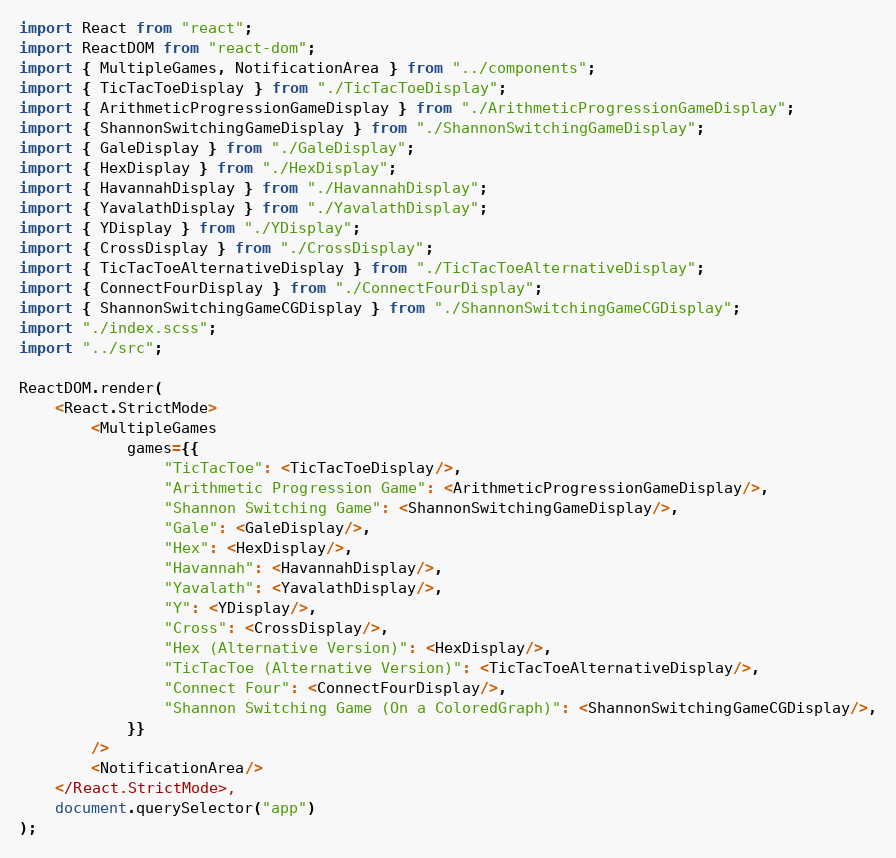Convert code to text. <code><loc_0><loc_0><loc_500><loc_500><_TypeScript_>import React from "react";
import ReactDOM from "react-dom";
import { MultipleGames, NotificationArea } from "../components";
import { TicTacToeDisplay } from "./TicTacToeDisplay";
import { ArithmeticProgressionGameDisplay } from "./ArithmeticProgressionGameDisplay";
import { ShannonSwitchingGameDisplay } from "./ShannonSwitchingGameDisplay";
import { GaleDisplay } from "./GaleDisplay";
import { HexDisplay } from "./HexDisplay";
import { HavannahDisplay } from "./HavannahDisplay";
import { YavalathDisplay } from "./YavalathDisplay";
import { YDisplay } from "./YDisplay";
import { CrossDisplay } from "./CrossDisplay";
import { TicTacToeAlternativeDisplay } from "./TicTacToeAlternativeDisplay";
import { ConnectFourDisplay } from "./ConnectFourDisplay";
import { ShannonSwitchingGameCGDisplay } from "./ShannonSwitchingGameCGDisplay";
import "./index.scss";
import "../src";

ReactDOM.render(
	<React.StrictMode>
		<MultipleGames
			games={{
				"TicTacToe": <TicTacToeDisplay/>,
				"Arithmetic Progression Game": <ArithmeticProgressionGameDisplay/>,
				"Shannon Switching Game": <ShannonSwitchingGameDisplay/>,
				"Gale": <GaleDisplay/>,
				"Hex": <HexDisplay/>,
				"Havannah": <HavannahDisplay/>,
				"Yavalath": <YavalathDisplay/>,
				"Y": <YDisplay/>,
				"Cross": <CrossDisplay/>,
				"Hex (Alternative Version)": <HexDisplay/>,
				"TicTacToe (Alternative Version)": <TicTacToeAlternativeDisplay/>,
				"Connect Four": <ConnectFourDisplay/>,
				"Shannon Switching Game (On a ColoredGraph)": <ShannonSwitchingGameCGDisplay/>,
			}}
		/>
		<NotificationArea/>
	</React.StrictMode>,
	document.querySelector("app")
);
</code> 